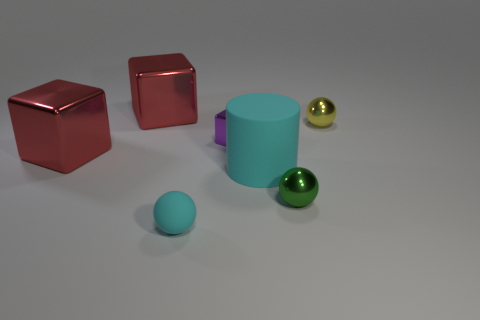Add 1 small cyan spheres. How many objects exist? 8 Subtract all cylinders. How many objects are left? 6 Subtract all green balls. Subtract all big cyan cylinders. How many objects are left? 5 Add 4 small purple blocks. How many small purple blocks are left? 5 Add 3 yellow spheres. How many yellow spheres exist? 4 Subtract 0 brown cylinders. How many objects are left? 7 